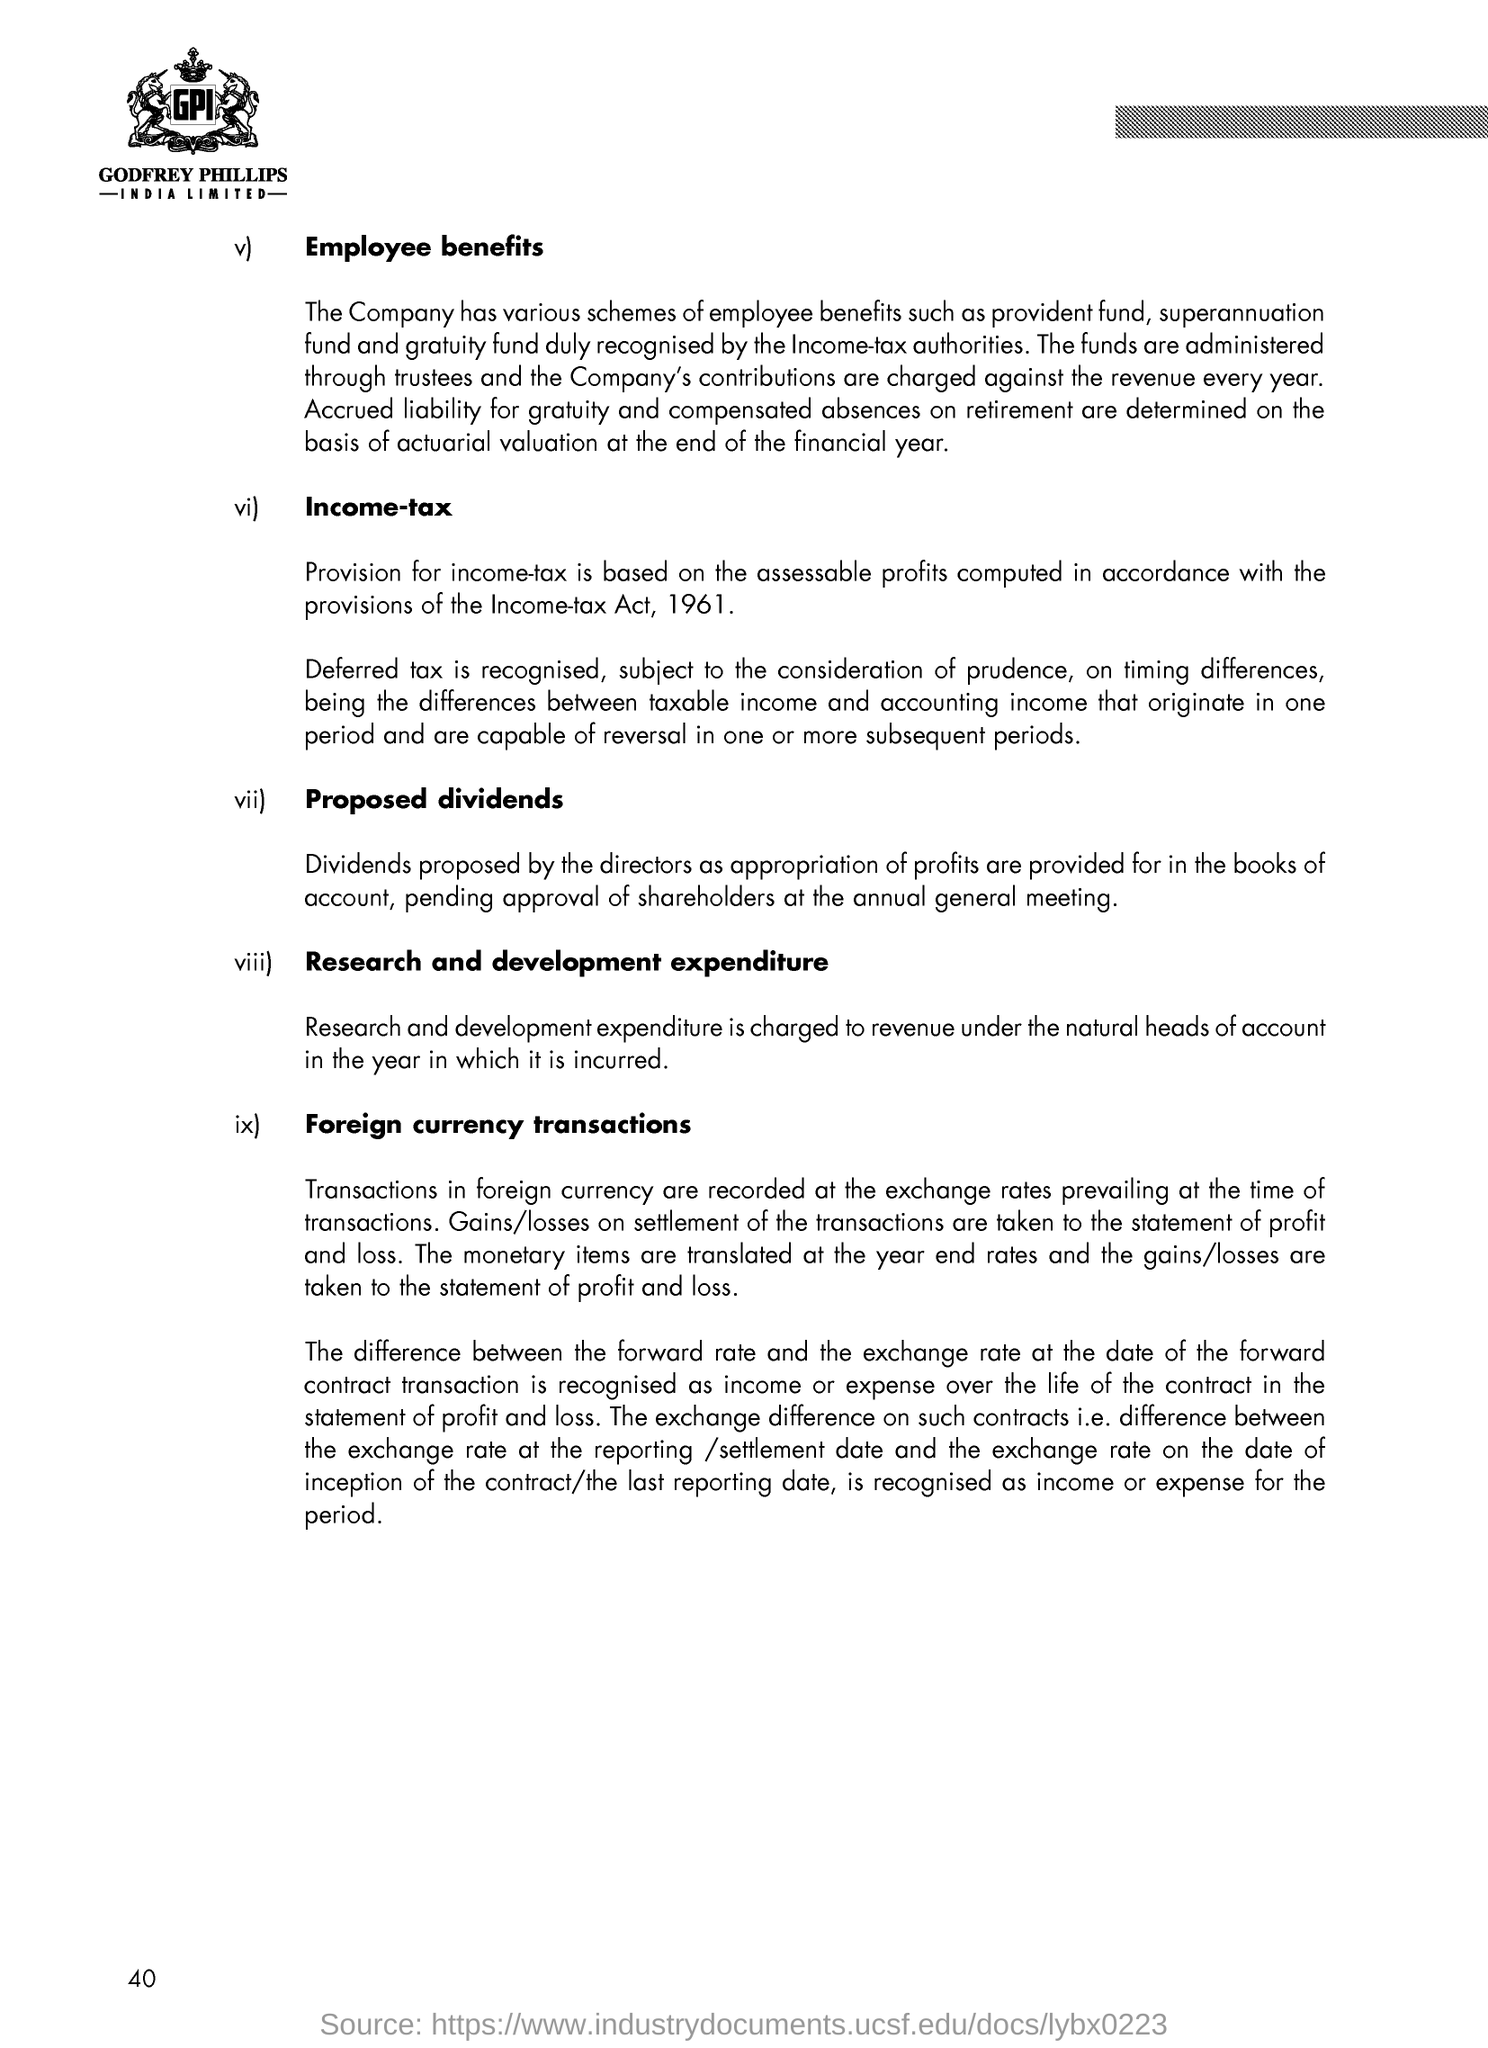What can you tell me about the company's provisions for income tax and dividends? Regarding income tax, the document states that the company's provision for income tax is based on assessable profits in accordance with the provisions of the Income-tax Act, 1961. They also recognize deferred tax, which relates to timing differences between taxable income and accounting income, which may reverse in future periods. As for dividends, they are proposed by the directors, drawn from profits, and are subject to approval by shareholders at the annual general meeting. 